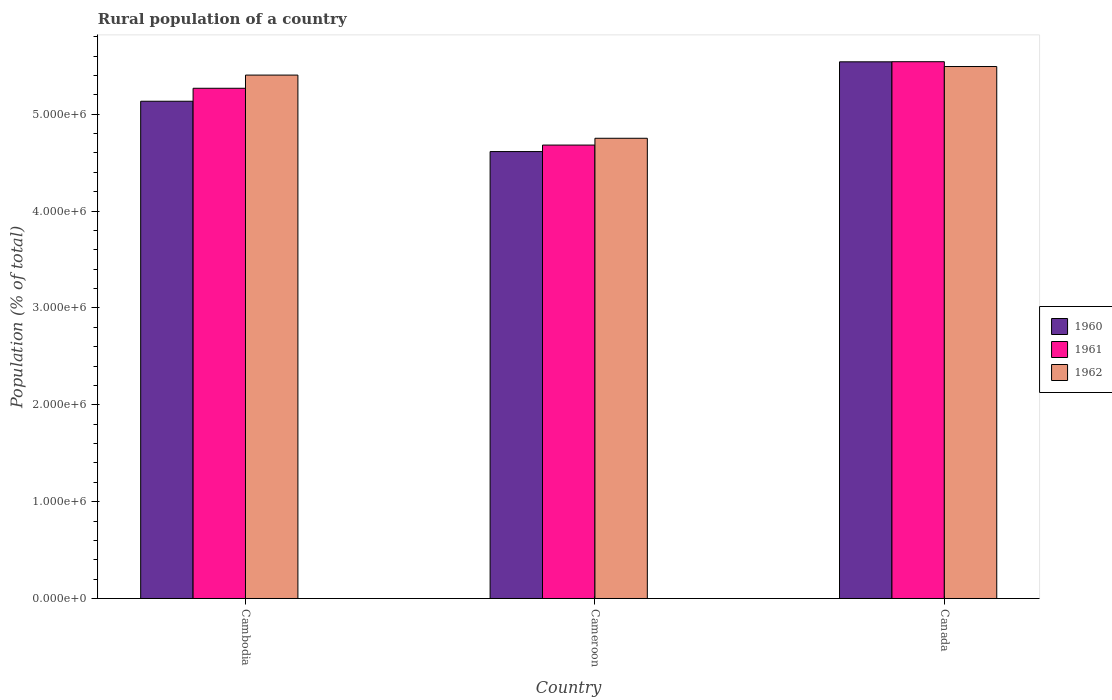How many different coloured bars are there?
Make the answer very short. 3. Are the number of bars per tick equal to the number of legend labels?
Your answer should be compact. Yes. Are the number of bars on each tick of the X-axis equal?
Offer a very short reply. Yes. What is the label of the 2nd group of bars from the left?
Offer a terse response. Cameroon. In how many cases, is the number of bars for a given country not equal to the number of legend labels?
Give a very brief answer. 0. What is the rural population in 1960 in Canada?
Provide a short and direct response. 5.54e+06. Across all countries, what is the maximum rural population in 1960?
Your answer should be very brief. 5.54e+06. Across all countries, what is the minimum rural population in 1962?
Offer a very short reply. 4.75e+06. In which country was the rural population in 1961 maximum?
Your answer should be compact. Canada. In which country was the rural population in 1960 minimum?
Offer a very short reply. Cameroon. What is the total rural population in 1961 in the graph?
Keep it short and to the point. 1.55e+07. What is the difference between the rural population in 1962 in Cambodia and that in Cameroon?
Ensure brevity in your answer.  6.52e+05. What is the difference between the rural population in 1962 in Cambodia and the rural population in 1960 in Cameroon?
Offer a terse response. 7.90e+05. What is the average rural population in 1961 per country?
Your response must be concise. 5.16e+06. What is the difference between the rural population of/in 1960 and rural population of/in 1962 in Canada?
Ensure brevity in your answer.  4.86e+04. What is the ratio of the rural population in 1961 in Cambodia to that in Canada?
Offer a very short reply. 0.95. What is the difference between the highest and the second highest rural population in 1962?
Make the answer very short. -6.52e+05. What is the difference between the highest and the lowest rural population in 1960?
Ensure brevity in your answer.  9.27e+05. What does the 1st bar from the right in Cameroon represents?
Offer a very short reply. 1962. How many bars are there?
Make the answer very short. 9. How many countries are there in the graph?
Offer a very short reply. 3. Are the values on the major ticks of Y-axis written in scientific E-notation?
Offer a very short reply. Yes. Does the graph contain any zero values?
Give a very brief answer. No. What is the title of the graph?
Offer a terse response. Rural population of a country. Does "1976" appear as one of the legend labels in the graph?
Your answer should be very brief. No. What is the label or title of the X-axis?
Provide a succinct answer. Country. What is the label or title of the Y-axis?
Your answer should be compact. Population (% of total). What is the Population (% of total) of 1960 in Cambodia?
Your answer should be very brief. 5.13e+06. What is the Population (% of total) of 1961 in Cambodia?
Your answer should be very brief. 5.27e+06. What is the Population (% of total) of 1962 in Cambodia?
Keep it short and to the point. 5.40e+06. What is the Population (% of total) in 1960 in Cameroon?
Your answer should be compact. 4.61e+06. What is the Population (% of total) in 1961 in Cameroon?
Provide a short and direct response. 4.68e+06. What is the Population (% of total) of 1962 in Cameroon?
Offer a very short reply. 4.75e+06. What is the Population (% of total) in 1960 in Canada?
Provide a short and direct response. 5.54e+06. What is the Population (% of total) in 1961 in Canada?
Your answer should be very brief. 5.54e+06. What is the Population (% of total) in 1962 in Canada?
Offer a very short reply. 5.49e+06. Across all countries, what is the maximum Population (% of total) in 1960?
Your answer should be very brief. 5.54e+06. Across all countries, what is the maximum Population (% of total) of 1961?
Give a very brief answer. 5.54e+06. Across all countries, what is the maximum Population (% of total) in 1962?
Keep it short and to the point. 5.49e+06. Across all countries, what is the minimum Population (% of total) in 1960?
Give a very brief answer. 4.61e+06. Across all countries, what is the minimum Population (% of total) in 1961?
Offer a very short reply. 4.68e+06. Across all countries, what is the minimum Population (% of total) of 1962?
Make the answer very short. 4.75e+06. What is the total Population (% of total) of 1960 in the graph?
Provide a succinct answer. 1.53e+07. What is the total Population (% of total) of 1961 in the graph?
Offer a very short reply. 1.55e+07. What is the total Population (% of total) in 1962 in the graph?
Your response must be concise. 1.56e+07. What is the difference between the Population (% of total) of 1960 in Cambodia and that in Cameroon?
Your response must be concise. 5.20e+05. What is the difference between the Population (% of total) of 1961 in Cambodia and that in Cameroon?
Keep it short and to the point. 5.86e+05. What is the difference between the Population (% of total) of 1962 in Cambodia and that in Cameroon?
Give a very brief answer. 6.52e+05. What is the difference between the Population (% of total) of 1960 in Cambodia and that in Canada?
Your answer should be compact. -4.07e+05. What is the difference between the Population (% of total) of 1961 in Cambodia and that in Canada?
Ensure brevity in your answer.  -2.74e+05. What is the difference between the Population (% of total) of 1962 in Cambodia and that in Canada?
Make the answer very short. -8.83e+04. What is the difference between the Population (% of total) of 1960 in Cameroon and that in Canada?
Give a very brief answer. -9.27e+05. What is the difference between the Population (% of total) in 1961 in Cameroon and that in Canada?
Ensure brevity in your answer.  -8.61e+05. What is the difference between the Population (% of total) in 1962 in Cameroon and that in Canada?
Give a very brief answer. -7.41e+05. What is the difference between the Population (% of total) in 1960 in Cambodia and the Population (% of total) in 1961 in Cameroon?
Provide a short and direct response. 4.52e+05. What is the difference between the Population (% of total) in 1960 in Cambodia and the Population (% of total) in 1962 in Cameroon?
Offer a terse response. 3.82e+05. What is the difference between the Population (% of total) in 1961 in Cambodia and the Population (% of total) in 1962 in Cameroon?
Keep it short and to the point. 5.16e+05. What is the difference between the Population (% of total) of 1960 in Cambodia and the Population (% of total) of 1961 in Canada?
Provide a short and direct response. -4.08e+05. What is the difference between the Population (% of total) in 1960 in Cambodia and the Population (% of total) in 1962 in Canada?
Ensure brevity in your answer.  -3.58e+05. What is the difference between the Population (% of total) of 1961 in Cambodia and the Population (% of total) of 1962 in Canada?
Your answer should be compact. -2.24e+05. What is the difference between the Population (% of total) in 1960 in Cameroon and the Population (% of total) in 1961 in Canada?
Give a very brief answer. -9.28e+05. What is the difference between the Population (% of total) of 1960 in Cameroon and the Population (% of total) of 1962 in Canada?
Provide a succinct answer. -8.78e+05. What is the difference between the Population (% of total) of 1961 in Cameroon and the Population (% of total) of 1962 in Canada?
Your answer should be very brief. -8.11e+05. What is the average Population (% of total) of 1960 per country?
Give a very brief answer. 5.10e+06. What is the average Population (% of total) of 1961 per country?
Keep it short and to the point. 5.16e+06. What is the average Population (% of total) of 1962 per country?
Offer a very short reply. 5.22e+06. What is the difference between the Population (% of total) of 1960 and Population (% of total) of 1961 in Cambodia?
Keep it short and to the point. -1.34e+05. What is the difference between the Population (% of total) of 1960 and Population (% of total) of 1962 in Cambodia?
Your answer should be very brief. -2.70e+05. What is the difference between the Population (% of total) of 1961 and Population (% of total) of 1962 in Cambodia?
Provide a succinct answer. -1.36e+05. What is the difference between the Population (% of total) of 1960 and Population (% of total) of 1961 in Cameroon?
Provide a succinct answer. -6.72e+04. What is the difference between the Population (% of total) of 1960 and Population (% of total) of 1962 in Cameroon?
Provide a succinct answer. -1.37e+05. What is the difference between the Population (% of total) in 1961 and Population (% of total) in 1962 in Cameroon?
Your answer should be very brief. -7.01e+04. What is the difference between the Population (% of total) in 1960 and Population (% of total) in 1961 in Canada?
Your response must be concise. -1092. What is the difference between the Population (% of total) of 1960 and Population (% of total) of 1962 in Canada?
Keep it short and to the point. 4.86e+04. What is the difference between the Population (% of total) of 1961 and Population (% of total) of 1962 in Canada?
Keep it short and to the point. 4.97e+04. What is the ratio of the Population (% of total) of 1960 in Cambodia to that in Cameroon?
Your answer should be compact. 1.11. What is the ratio of the Population (% of total) of 1961 in Cambodia to that in Cameroon?
Ensure brevity in your answer.  1.13. What is the ratio of the Population (% of total) of 1962 in Cambodia to that in Cameroon?
Keep it short and to the point. 1.14. What is the ratio of the Population (% of total) of 1960 in Cambodia to that in Canada?
Keep it short and to the point. 0.93. What is the ratio of the Population (% of total) of 1961 in Cambodia to that in Canada?
Offer a very short reply. 0.95. What is the ratio of the Population (% of total) in 1962 in Cambodia to that in Canada?
Offer a very short reply. 0.98. What is the ratio of the Population (% of total) of 1960 in Cameroon to that in Canada?
Ensure brevity in your answer.  0.83. What is the ratio of the Population (% of total) of 1961 in Cameroon to that in Canada?
Provide a succinct answer. 0.84. What is the ratio of the Population (% of total) in 1962 in Cameroon to that in Canada?
Your answer should be compact. 0.87. What is the difference between the highest and the second highest Population (% of total) in 1960?
Make the answer very short. 4.07e+05. What is the difference between the highest and the second highest Population (% of total) in 1961?
Offer a terse response. 2.74e+05. What is the difference between the highest and the second highest Population (% of total) in 1962?
Ensure brevity in your answer.  8.83e+04. What is the difference between the highest and the lowest Population (% of total) of 1960?
Make the answer very short. 9.27e+05. What is the difference between the highest and the lowest Population (% of total) in 1961?
Ensure brevity in your answer.  8.61e+05. What is the difference between the highest and the lowest Population (% of total) in 1962?
Your answer should be very brief. 7.41e+05. 